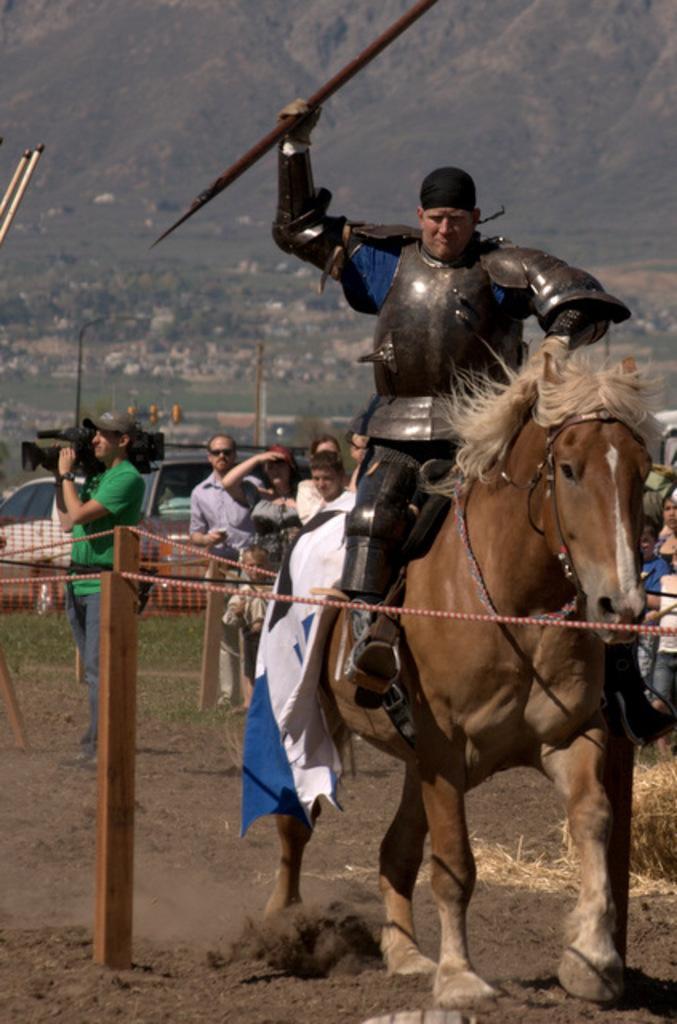Describe this image in one or two sentences. In this image we can see a group of people standing. A person is riding a horse and holding an object. There are few hills in the image. There is a lake in the image. There are many houses in the image. There are few vehicles in the image. There is an object at the left most of the image. There is a rope barrier in the image. 